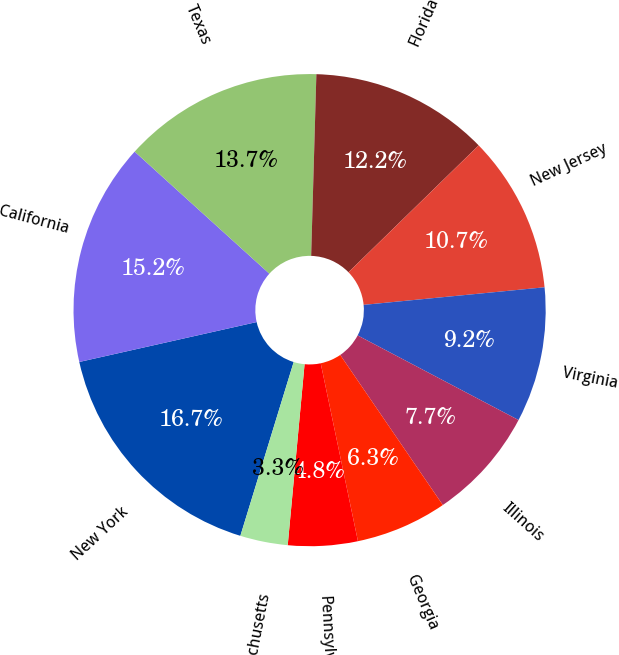<chart> <loc_0><loc_0><loc_500><loc_500><pie_chart><fcel>New York<fcel>California<fcel>Texas<fcel>Florida<fcel>New Jersey<fcel>Virginia<fcel>Illinois<fcel>Georgia<fcel>Pennsylvania<fcel>Massachusetts<nl><fcel>16.74%<fcel>15.24%<fcel>13.74%<fcel>12.25%<fcel>10.75%<fcel>9.25%<fcel>7.75%<fcel>6.26%<fcel>4.76%<fcel>3.26%<nl></chart> 